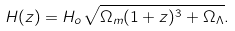<formula> <loc_0><loc_0><loc_500><loc_500>H ( z ) = H _ { o } \sqrt { \Omega _ { m } ( 1 + z ) ^ { 3 } + \Omega _ { \Lambda } } .</formula> 